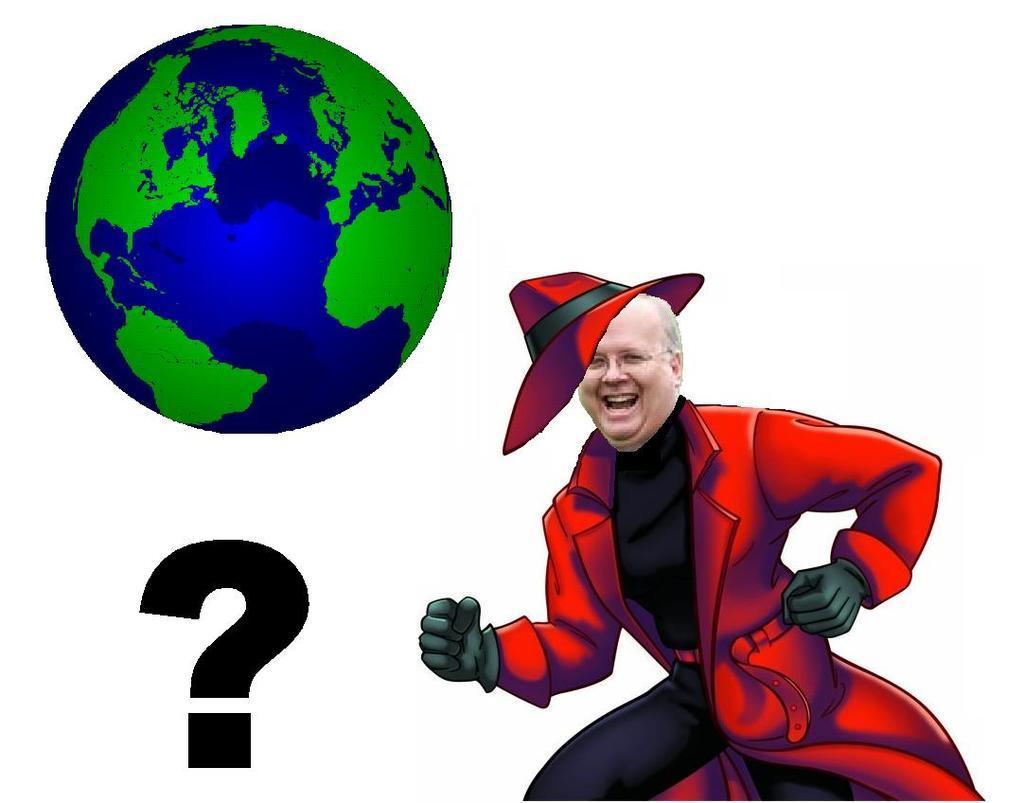In one or two sentences, can you explain what this image depicts? In this picture we can see edited image. In front we can see old man wearing a red color coat, smiling and giving a pose into the camera. Above we can see blue and green color globe. 